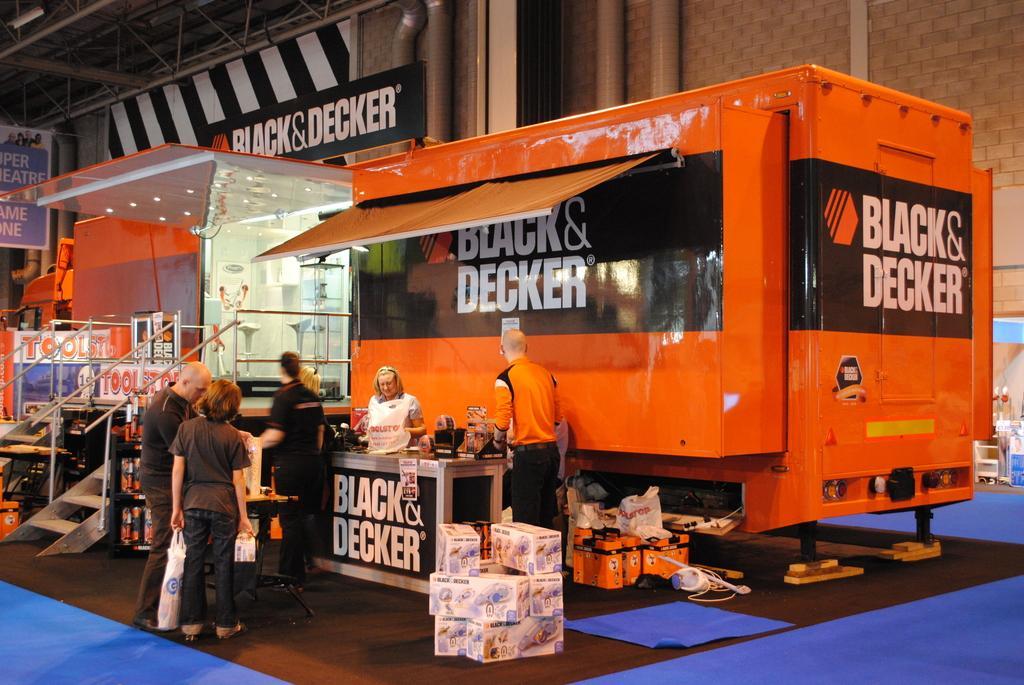Could you give a brief overview of what you see in this image? In this image we can see a truck containing some chairs, lights, a staircase, roof and some text on it. We can also see a table with some objects on it, a group of people and some objects placed on the floor. On the backside we can see a building with pipes, roof and a signboard with some text on it. 